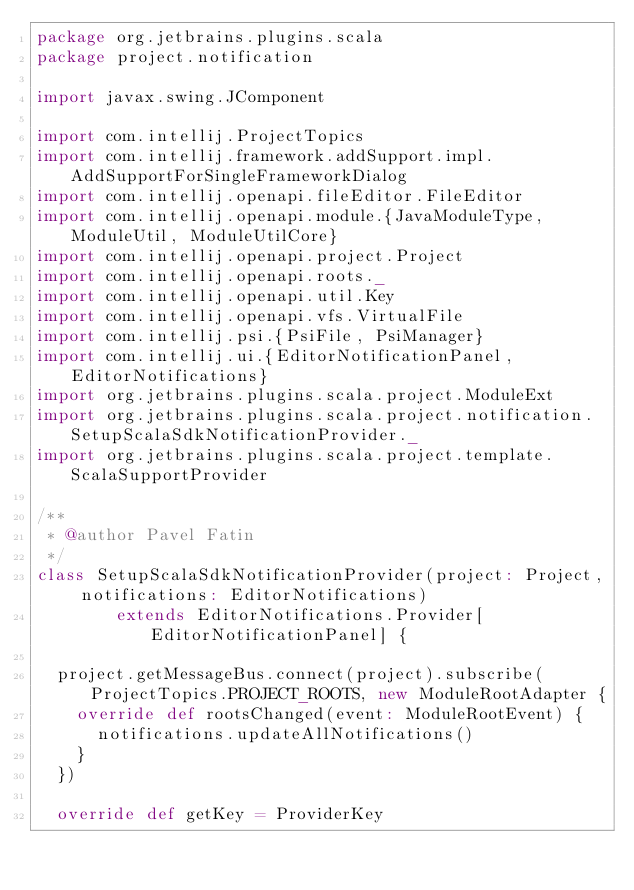Convert code to text. <code><loc_0><loc_0><loc_500><loc_500><_Scala_>package org.jetbrains.plugins.scala
package project.notification

import javax.swing.JComponent

import com.intellij.ProjectTopics
import com.intellij.framework.addSupport.impl.AddSupportForSingleFrameworkDialog
import com.intellij.openapi.fileEditor.FileEditor
import com.intellij.openapi.module.{JavaModuleType, ModuleUtil, ModuleUtilCore}
import com.intellij.openapi.project.Project
import com.intellij.openapi.roots._
import com.intellij.openapi.util.Key
import com.intellij.openapi.vfs.VirtualFile
import com.intellij.psi.{PsiFile, PsiManager}
import com.intellij.ui.{EditorNotificationPanel, EditorNotifications}
import org.jetbrains.plugins.scala.project.ModuleExt
import org.jetbrains.plugins.scala.project.notification.SetupScalaSdkNotificationProvider._
import org.jetbrains.plugins.scala.project.template.ScalaSupportProvider

/**
 * @author Pavel Fatin
 */
class SetupScalaSdkNotificationProvider(project: Project, notifications: EditorNotifications)
        extends EditorNotifications.Provider[EditorNotificationPanel] {

  project.getMessageBus.connect(project).subscribe(ProjectTopics.PROJECT_ROOTS, new ModuleRootAdapter {
    override def rootsChanged(event: ModuleRootEvent) {
      notifications.updateAllNotifications()
    }
  })

  override def getKey = ProviderKey
</code> 